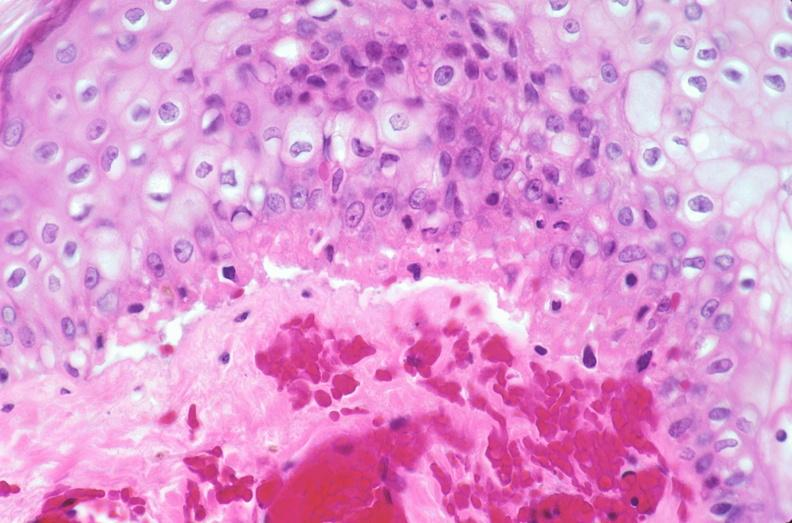does this image show skin, epidermolysis bullosa?
Answer the question using a single word or phrase. Yes 